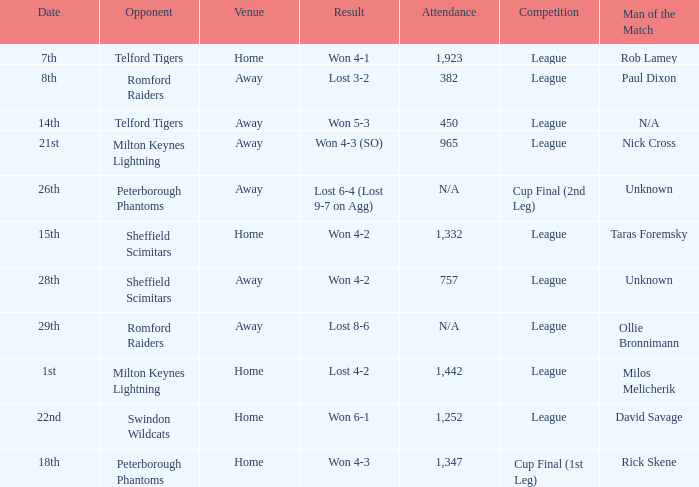On what date was the venue Away and the result was lost 6-4 (lost 9-7 on agg)? 26th. 